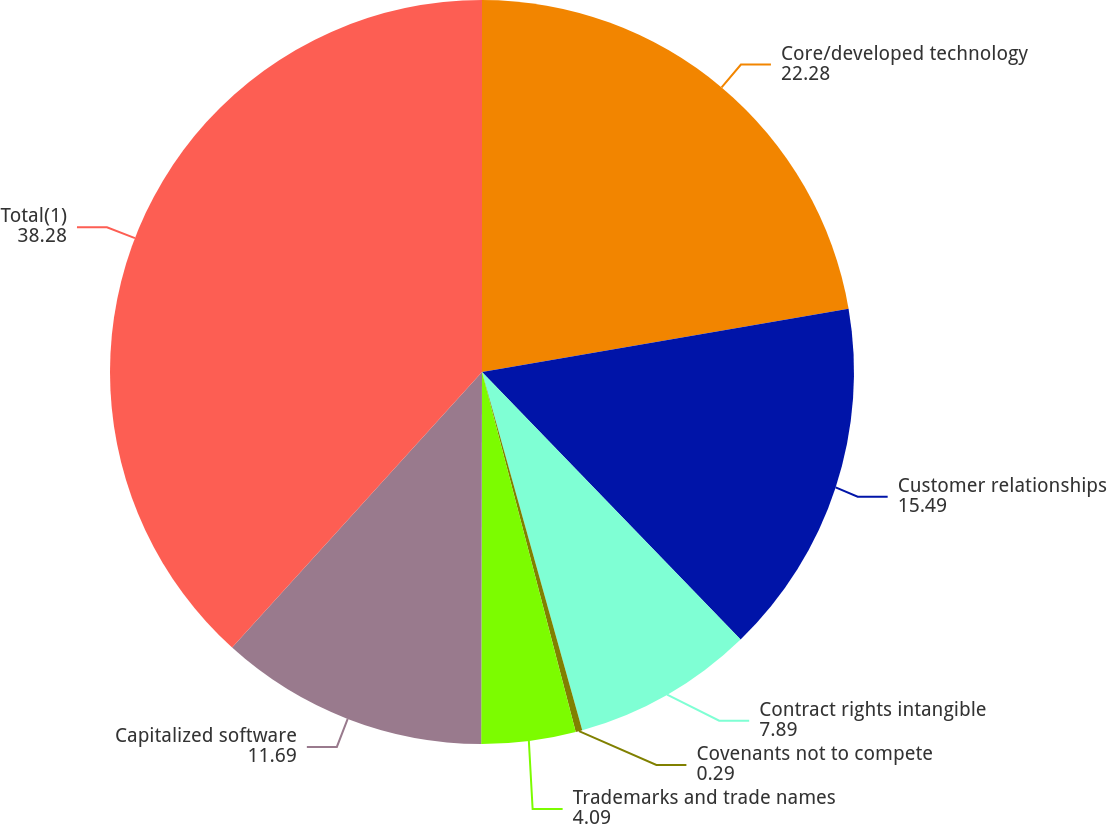Convert chart. <chart><loc_0><loc_0><loc_500><loc_500><pie_chart><fcel>Core/developed technology<fcel>Customer relationships<fcel>Contract rights intangible<fcel>Covenants not to compete<fcel>Trademarks and trade names<fcel>Capitalized software<fcel>Total(1)<nl><fcel>22.28%<fcel>15.49%<fcel>7.89%<fcel>0.29%<fcel>4.09%<fcel>11.69%<fcel>38.28%<nl></chart> 